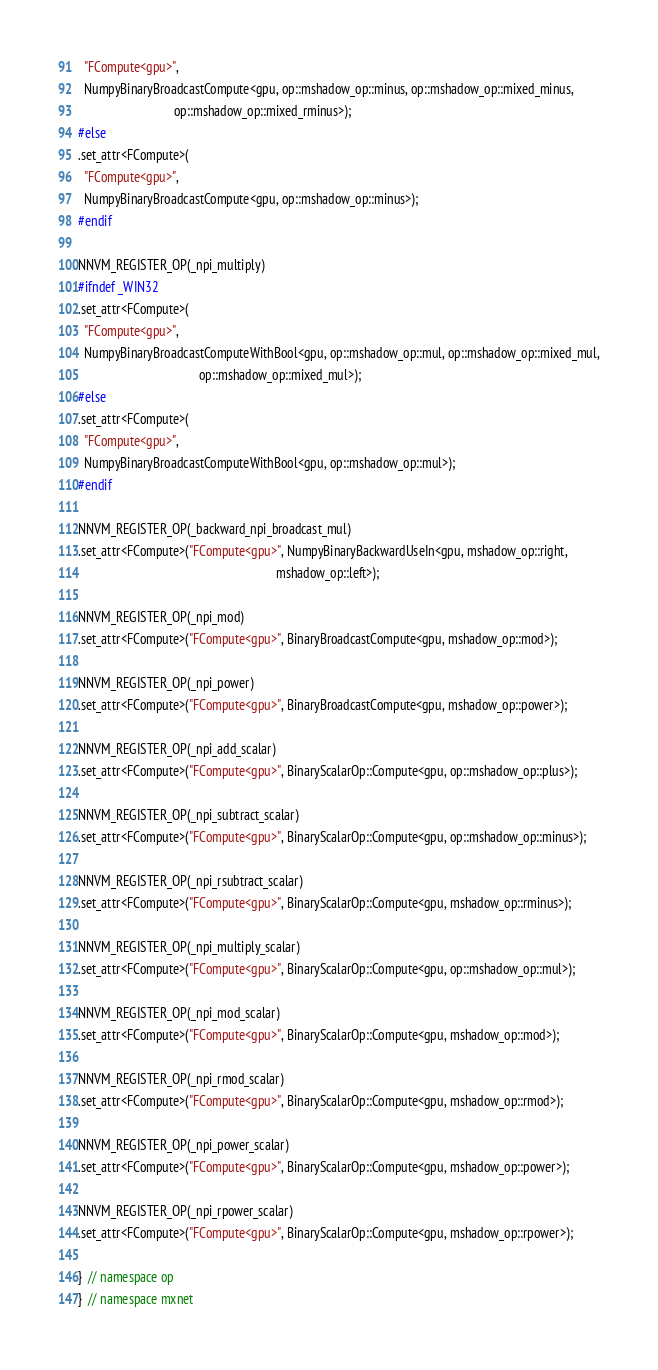Convert code to text. <code><loc_0><loc_0><loc_500><loc_500><_Cuda_>  "FCompute<gpu>",
  NumpyBinaryBroadcastCompute<gpu, op::mshadow_op::minus, op::mshadow_op::mixed_minus,
                              op::mshadow_op::mixed_rminus>);
#else
.set_attr<FCompute>(
  "FCompute<gpu>",
  NumpyBinaryBroadcastCompute<gpu, op::mshadow_op::minus>);
#endif

NNVM_REGISTER_OP(_npi_multiply)
#ifndef _WIN32
.set_attr<FCompute>(
  "FCompute<gpu>",
  NumpyBinaryBroadcastComputeWithBool<gpu, op::mshadow_op::mul, op::mshadow_op::mixed_mul,
                                      op::mshadow_op::mixed_mul>);
#else
.set_attr<FCompute>(
  "FCompute<gpu>",
  NumpyBinaryBroadcastComputeWithBool<gpu, op::mshadow_op::mul>);
#endif

NNVM_REGISTER_OP(_backward_npi_broadcast_mul)
.set_attr<FCompute>("FCompute<gpu>", NumpyBinaryBackwardUseIn<gpu, mshadow_op::right,
                                                              mshadow_op::left>);

NNVM_REGISTER_OP(_npi_mod)
.set_attr<FCompute>("FCompute<gpu>", BinaryBroadcastCompute<gpu, mshadow_op::mod>);

NNVM_REGISTER_OP(_npi_power)
.set_attr<FCompute>("FCompute<gpu>", BinaryBroadcastCompute<gpu, mshadow_op::power>);

NNVM_REGISTER_OP(_npi_add_scalar)
.set_attr<FCompute>("FCompute<gpu>", BinaryScalarOp::Compute<gpu, op::mshadow_op::plus>);

NNVM_REGISTER_OP(_npi_subtract_scalar)
.set_attr<FCompute>("FCompute<gpu>", BinaryScalarOp::Compute<gpu, op::mshadow_op::minus>);

NNVM_REGISTER_OP(_npi_rsubtract_scalar)
.set_attr<FCompute>("FCompute<gpu>", BinaryScalarOp::Compute<gpu, mshadow_op::rminus>);

NNVM_REGISTER_OP(_npi_multiply_scalar)
.set_attr<FCompute>("FCompute<gpu>", BinaryScalarOp::Compute<gpu, op::mshadow_op::mul>);

NNVM_REGISTER_OP(_npi_mod_scalar)
.set_attr<FCompute>("FCompute<gpu>", BinaryScalarOp::Compute<gpu, mshadow_op::mod>);

NNVM_REGISTER_OP(_npi_rmod_scalar)
.set_attr<FCompute>("FCompute<gpu>", BinaryScalarOp::Compute<gpu, mshadow_op::rmod>);

NNVM_REGISTER_OP(_npi_power_scalar)
.set_attr<FCompute>("FCompute<gpu>", BinaryScalarOp::Compute<gpu, mshadow_op::power>);

NNVM_REGISTER_OP(_npi_rpower_scalar)
.set_attr<FCompute>("FCompute<gpu>", BinaryScalarOp::Compute<gpu, mshadow_op::rpower>);

}  // namespace op
}  // namespace mxnet
</code> 